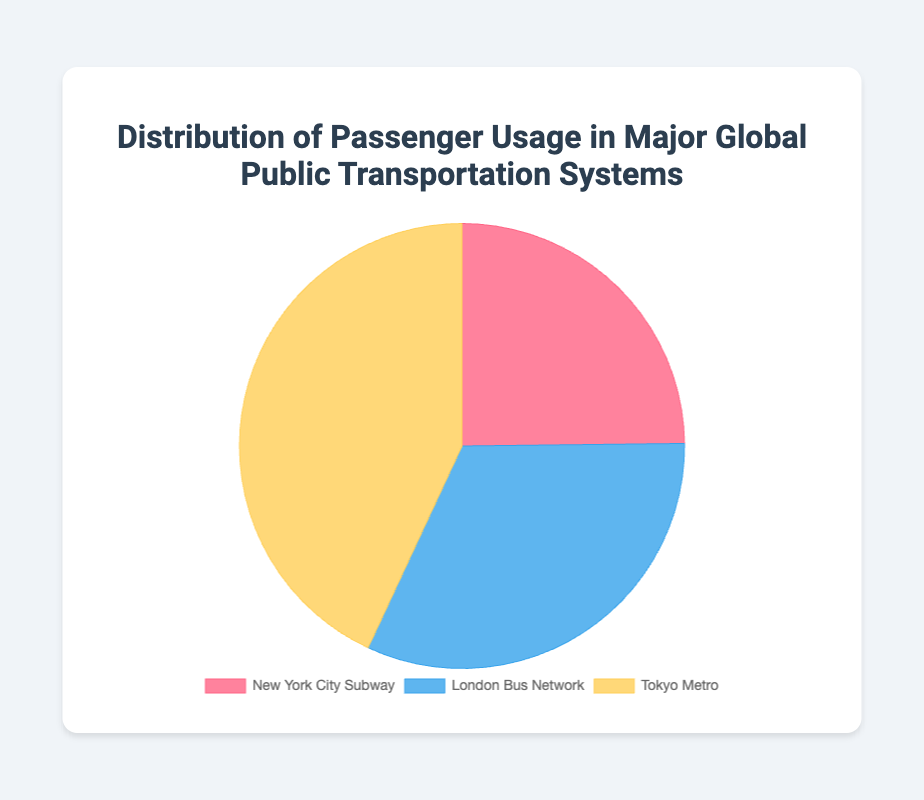What are the three major public transportation systems in the figure? The three major public transportation systems are listed in the legend of the pie chart: New York City Subway, London Bus Network, and Tokyo Metro.
Answer: New York City Subway, London Bus Network, Tokyo Metro Which public transportation system has the highest passenger usage? By looking at the sizes of the pie chart sections, the Tokyo Metro has the largest segment, indicating the highest passenger usage.
Answer: Tokyo Metro What is the percentage share of the annual passenger count for the New York City Subway? The New York City Subway's passenger count is 1.7 billion. Summing up counts from all systems: 1.7B + 2.2B + 2.95B = 6.85B. The percentage share is (1.7B / 6.85B) * 100 ≈ 24.8%.
Answer: 24.8% How does the passenger usage of the London Bus Network compare to the New York City Subway? The London Bus Network has 2.2 billion passengers versus the New York City Subway's 1.7 billion. Therefore, the London Bus Network has 2.2B - 1.7B = 0.5B more passengers.
Answer: 0.5 billion more Arrange the transportation systems in descending order of passenger usage. By looking at the chart sizes, the order from highest to lowest is Tokyo Metro (2.95B), London Bus Network (2.2B), and New York City Subway (1.7B).
Answer: Tokyo Metro, London Bus Network, New York City Subway What is the combined annual passenger usage of the London Bus Network and Tokyo Metro? Summing up the passenger counts of London Bus Network and Tokyo Metro: 2.2B + 2.95B = 5.15B.
Answer: 5.15 billion What is the visual color representation of the Tokyo Metro in the pie chart? The Tokyo Metro is represented by the largest slice in the chart, which is colored yellow.
Answer: Yellow Is the New York City Subway's passenger count greater than the difference between the Tokyo Metro and the London Bus Network? Calculating the difference between Tokyo Metro (2.95B) and London Bus Network (2.2B) gives 2.95B - 2.2B = 0.75B. Comparing this with New York City Subway's 1.7B, 1.7B > 0.75B.
Answer: Yes 